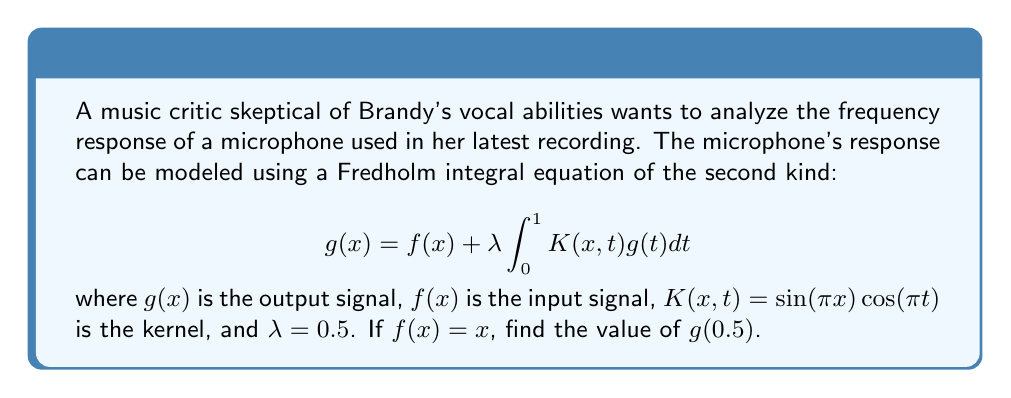Can you answer this question? To solve this problem, we'll follow these steps:

1) First, we need to substitute the given values into the Fredholm integral equation:

   $$g(x) = x + 0.5 \int_{0}^{1} \sin(\pi x)\cos(\pi t)g(t)dt$$

2) We can assume that $g(x)$ has the form:

   $$g(x) = Ax + B\sin(\pi x)$$

   where $A$ and $B$ are constants to be determined.

3) Substituting this into the integral equation:

   $$Ax + B\sin(\pi x) = x + 0.5 \int_{0}^{1} \sin(\pi x)\cos(\pi t)(At + B\sin(\pi t))dt$$

4) Simplify the right-hand side:

   $$x + 0.5\sin(\pi x) \int_{0}^{1} \cos(\pi t)(At + B\sin(\pi t))dt$$

5) Evaluate the integral:

   $$x + 0.5\sin(\pi x) \left[\frac{A}{\pi}\sin(\pi t) + \frac{B}{2}\right]_{0}^{1}$$

   $$= x + 0.5\sin(\pi x) \cdot \frac{B}{2}$$

6) Comparing coefficients:

   $A = 1$
   $\frac{B}{4} = B$

7) Solving for B:

   $B = 0$ or $B = \frac{4}{3}$

   Since $B = 0$ doesn't satisfy the equation, we take $B = \frac{4}{3}$

8) Therefore, the solution is:

   $$g(x) = x + \frac{4}{3}\sin(\pi x)$$

9) To find $g(0.5)$, we substitute $x = 0.5$:

   $$g(0.5) = 0.5 + \frac{4}{3}\sin(\pi \cdot 0.5) = 0.5 + \frac{4}{3} = \frac{11}{6}$$
Answer: $\frac{11}{6}$ 